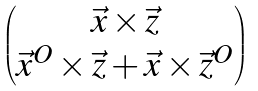Convert formula to latex. <formula><loc_0><loc_0><loc_500><loc_500>\begin{pmatrix} \vec { x } \times \vec { z } \\ \vec { x } ^ { O } \times \vec { z } + \vec { x } \times \vec { z } ^ { O } \end{pmatrix}</formula> 